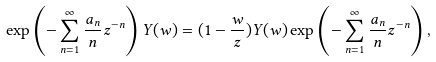<formula> <loc_0><loc_0><loc_500><loc_500>\exp \left ( - \sum ^ { \infty } _ { n = 1 } \frac { a _ { n } } { n } z ^ { - n } \right ) Y ( w ) = ( 1 - \frac { w } { z } ) Y ( w ) \exp \left ( - \sum ^ { \infty } _ { n = 1 } \frac { a _ { n } } { n } z ^ { - n } \right ) ,</formula> 